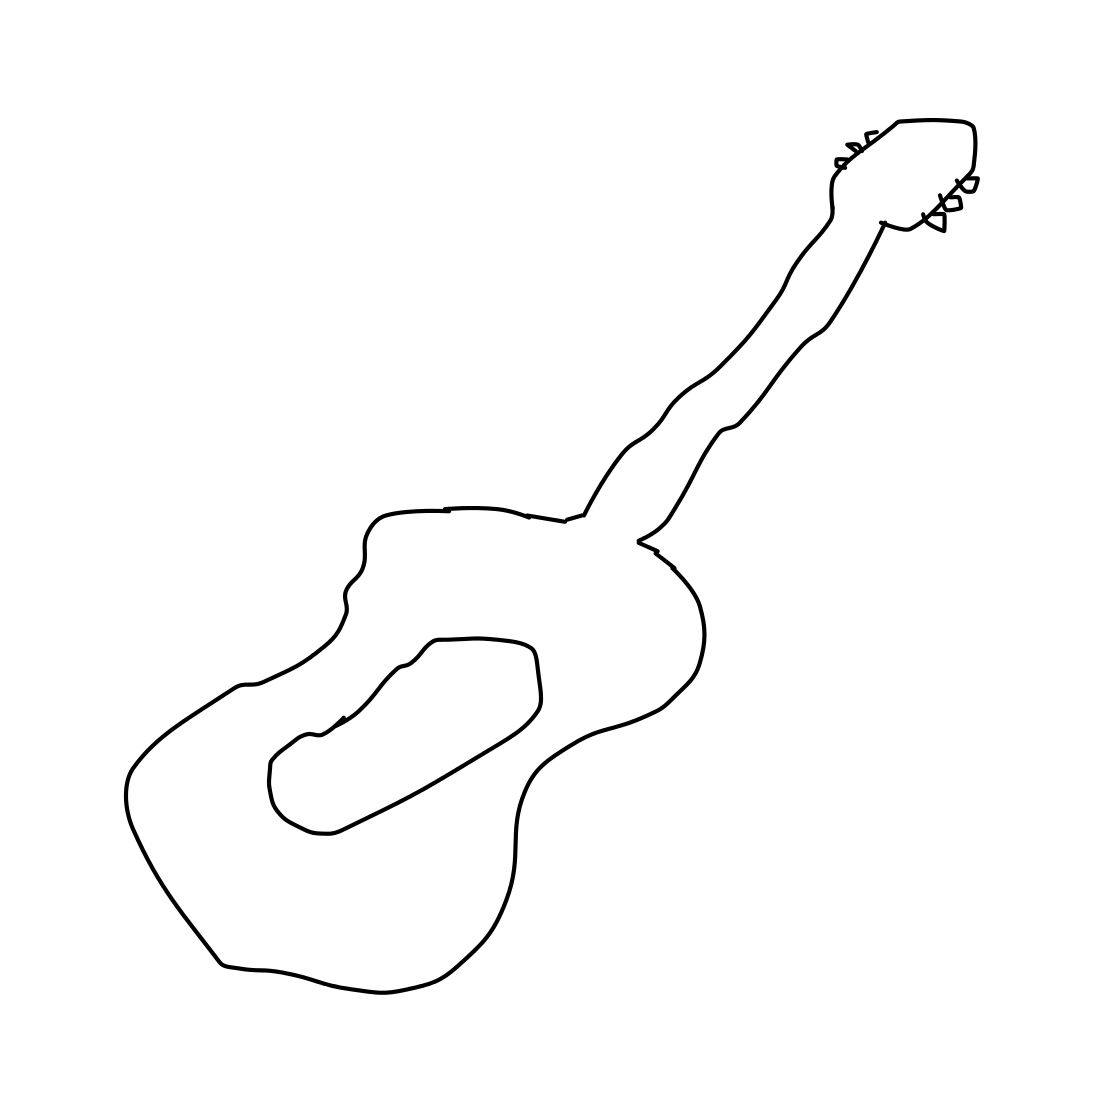What might be the setting or environment ideal for this kind of guitar? This type of guitar, with its classical design, is often used in settings that require soft, melodic sounds such as in classical music concerts, intimate live gigs, or personal enjoyment in a quiet setting at home. Could this style of guitar be used in other genres of music? Certainly, while it's tailored for classical music, creative musicians also use classical guitars in folk, Latin music, and even some modern acoustic sessions, showcasing its versatility. 